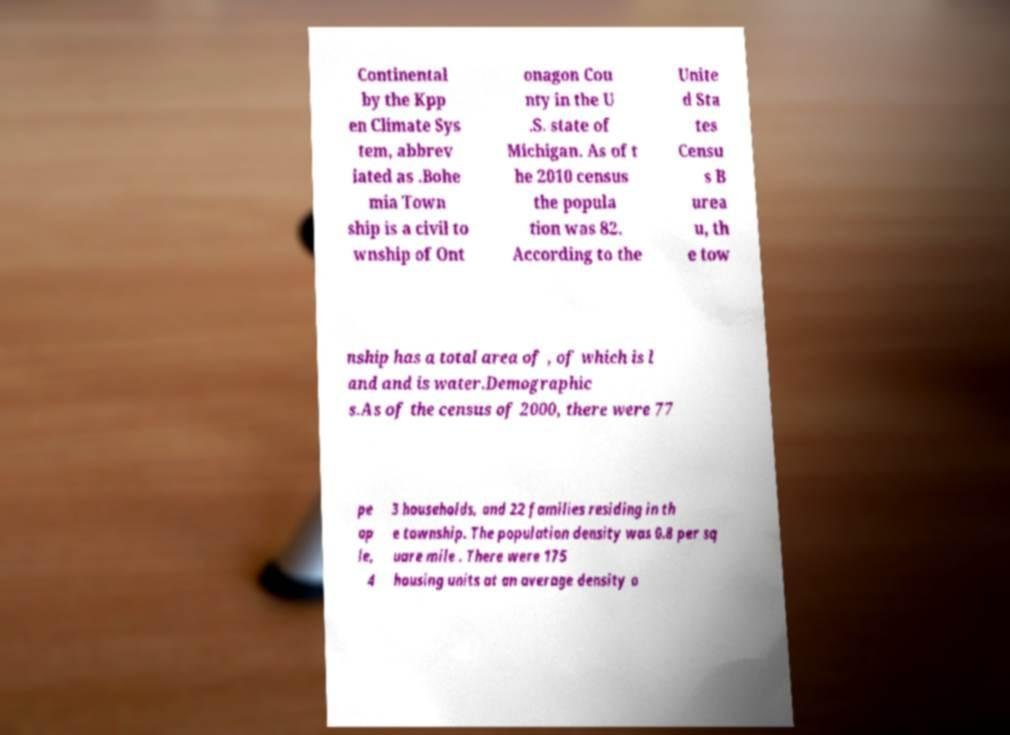What messages or text are displayed in this image? I need them in a readable, typed format. Continental by the Kpp en Climate Sys tem, abbrev iated as .Bohe mia Town ship is a civil to wnship of Ont onagon Cou nty in the U .S. state of Michigan. As of t he 2010 census the popula tion was 82. According to the Unite d Sta tes Censu s B urea u, th e tow nship has a total area of , of which is l and and is water.Demographic s.As of the census of 2000, there were 77 pe op le, 4 3 households, and 22 families residing in th e township. The population density was 0.8 per sq uare mile . There were 175 housing units at an average density o 